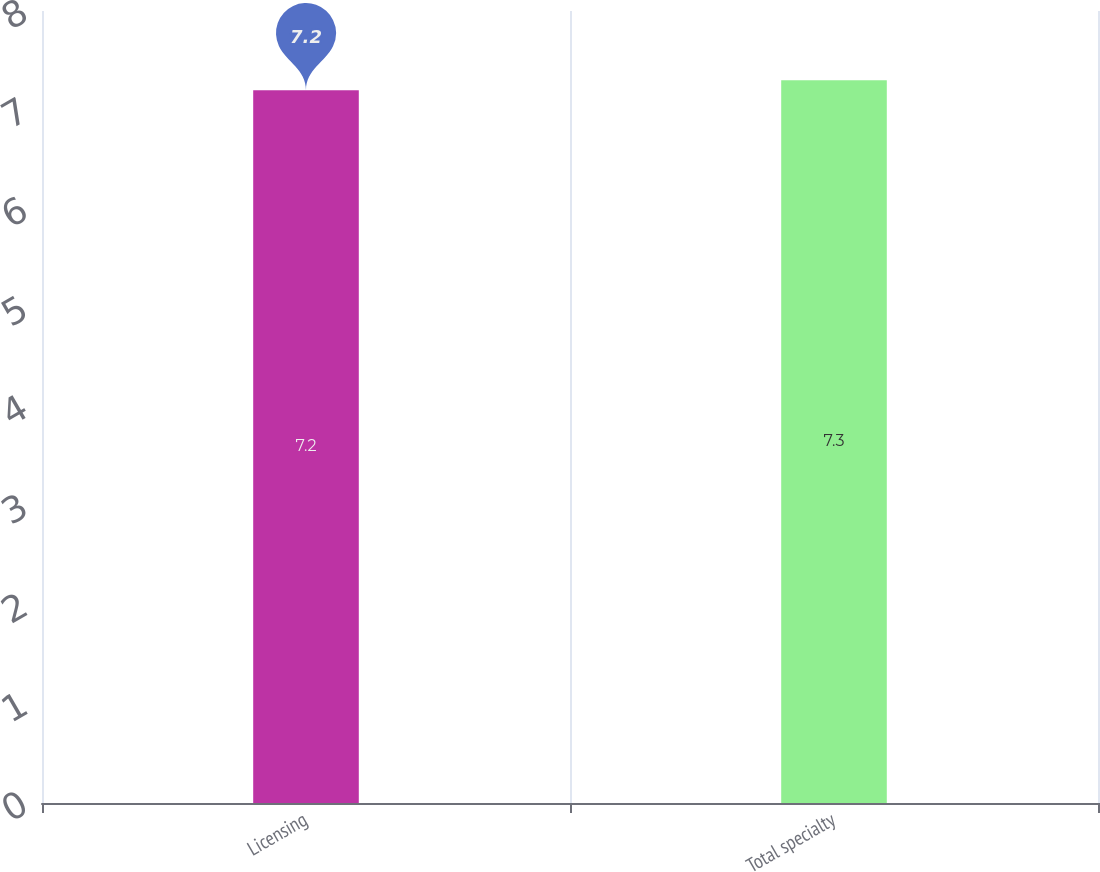Convert chart to OTSL. <chart><loc_0><loc_0><loc_500><loc_500><bar_chart><fcel>Licensing<fcel>Total specialty<nl><fcel>7.2<fcel>7.3<nl></chart> 